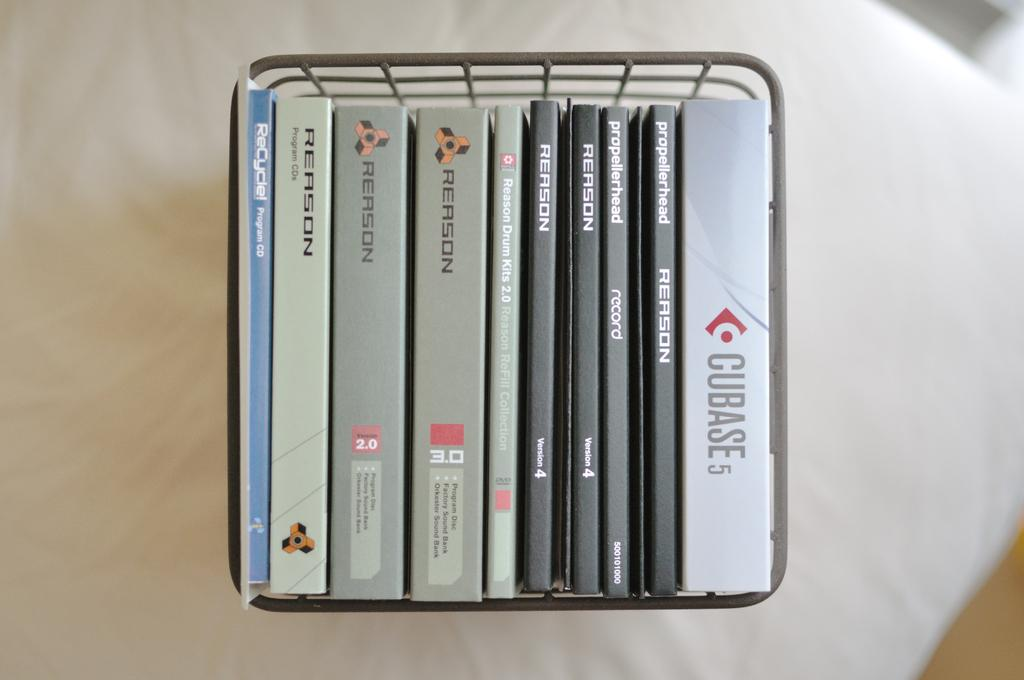<image>
Create a compact narrative representing the image presented. A wire basket holds CD sleeves, including one for Cubase 5. 